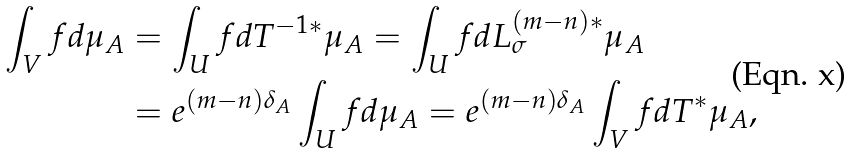Convert formula to latex. <formula><loc_0><loc_0><loc_500><loc_500>\int _ { V } f d \mu _ { A } & = \int _ { U } f d T ^ { - 1 * } \mu _ { A } = \int _ { U } f d L _ { \sigma } ^ { ( m - n ) * } \mu _ { A } \\ & = e ^ { ( m - n ) \delta _ { A } } \int _ { U } f d \mu _ { A } = e ^ { ( m - n ) \delta _ { A } } \int _ { V } f d T ^ { * } \mu _ { A } ,</formula> 